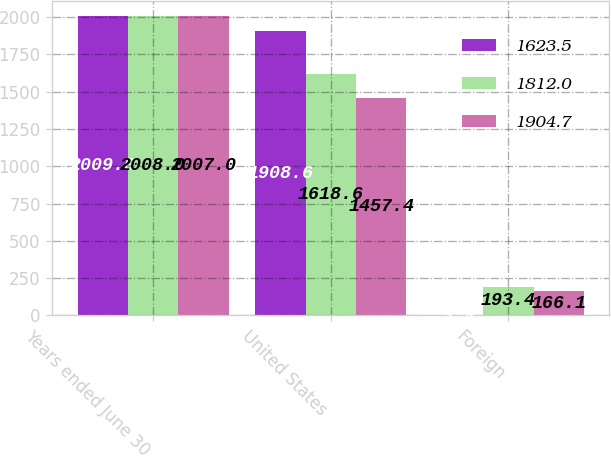<chart> <loc_0><loc_0><loc_500><loc_500><stacked_bar_chart><ecel><fcel>Years ended June 30<fcel>United States<fcel>Foreign<nl><fcel>1623.5<fcel>2009<fcel>1908.6<fcel>3.9<nl><fcel>1812<fcel>2008<fcel>1618.6<fcel>193.4<nl><fcel>1904.7<fcel>2007<fcel>1457.4<fcel>166.1<nl></chart> 